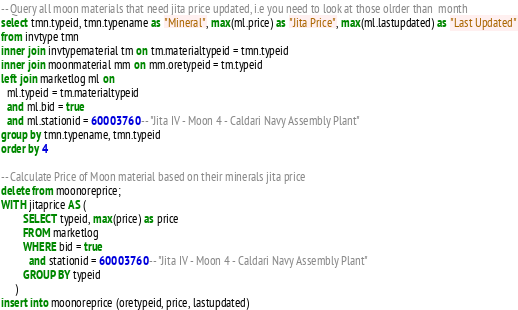<code> <loc_0><loc_0><loc_500><loc_500><_SQL_>-- Query all moon materials that need jita price updated, i.e you need to look at those olrder than  month
select tmn.typeid, tmn.typename as "Mineral", max(ml.price) as "Jita Price", max(ml.lastupdated) as "Last Updated"
from invtype tmn
inner join invtypematerial tm on tm.materialtypeid = tmn.typeid
inner join moonmaterial mm on mm.oretypeid = tm.typeid
left join marketlog ml on
  ml.typeid = tm.materialtypeid
  and ml.bid = true
  and ml.stationid = 60003760 -- "Jita IV - Moon 4 - Caldari Navy Assembly Plant"
group by tmn.typename, tmn.typeid
order by 4

-- Calculate Price of Moon material based on their minerals jita price
delete from moonoreprice;
WITH jitaprice AS (
        SELECT typeid, max(price) as price
        FROM marketlog
        WHERE bid = true
          and stationid = 60003760 -- "Jita IV - Moon 4 - Caldari Navy Assembly Plant"
        GROUP BY typeid
     )
insert into moonoreprice (oretypeid, price, lastupdated)</code> 